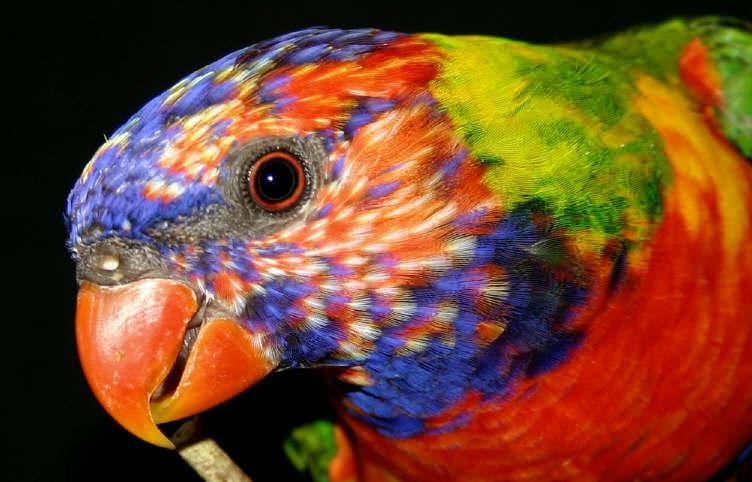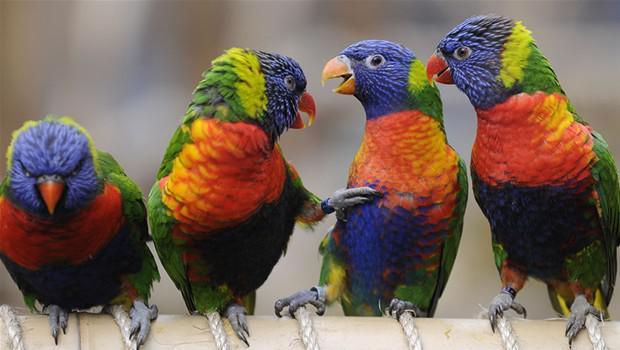The first image is the image on the left, the second image is the image on the right. Assess this claim about the two images: "An image features a horizontal row of at least four perched blue-headed parrots.". Correct or not? Answer yes or no. Yes. 